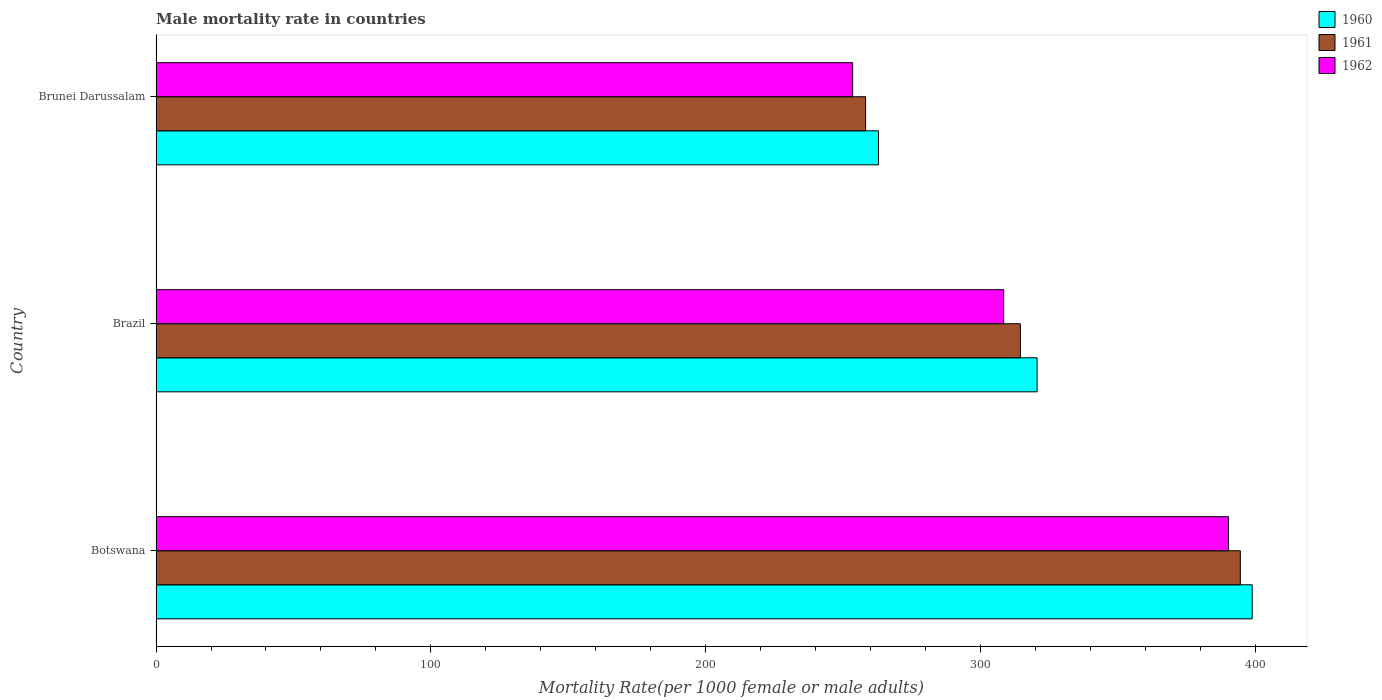How many groups of bars are there?
Offer a very short reply. 3. What is the label of the 3rd group of bars from the top?
Provide a succinct answer. Botswana. What is the male mortality rate in 1961 in Botswana?
Your answer should be compact. 394.41. Across all countries, what is the maximum male mortality rate in 1961?
Give a very brief answer. 394.41. Across all countries, what is the minimum male mortality rate in 1961?
Give a very brief answer. 258.09. In which country was the male mortality rate in 1960 maximum?
Provide a short and direct response. Botswana. In which country was the male mortality rate in 1962 minimum?
Offer a terse response. Brunei Darussalam. What is the total male mortality rate in 1961 in the graph?
Your answer should be compact. 966.9. What is the difference between the male mortality rate in 1960 in Botswana and that in Brazil?
Provide a short and direct response. 78.24. What is the difference between the male mortality rate in 1960 in Brunei Darussalam and the male mortality rate in 1962 in Botswana?
Ensure brevity in your answer.  -127.32. What is the average male mortality rate in 1962 per country?
Your response must be concise. 317.27. What is the difference between the male mortality rate in 1961 and male mortality rate in 1962 in Botswana?
Give a very brief answer. 4.3. What is the ratio of the male mortality rate in 1961 in Botswana to that in Brunei Darussalam?
Make the answer very short. 1.53. What is the difference between the highest and the second highest male mortality rate in 1962?
Offer a very short reply. 81.78. What is the difference between the highest and the lowest male mortality rate in 1960?
Your response must be concise. 135.93. In how many countries, is the male mortality rate in 1962 greater than the average male mortality rate in 1962 taken over all countries?
Offer a very short reply. 1. Is it the case that in every country, the sum of the male mortality rate in 1961 and male mortality rate in 1960 is greater than the male mortality rate in 1962?
Ensure brevity in your answer.  Yes. Are all the bars in the graph horizontal?
Offer a very short reply. Yes. How many countries are there in the graph?
Make the answer very short. 3. How many legend labels are there?
Offer a very short reply. 3. How are the legend labels stacked?
Give a very brief answer. Vertical. What is the title of the graph?
Make the answer very short. Male mortality rate in countries. Does "2008" appear as one of the legend labels in the graph?
Your answer should be compact. No. What is the label or title of the X-axis?
Provide a succinct answer. Mortality Rate(per 1000 female or male adults). What is the Mortality Rate(per 1000 female or male adults) in 1960 in Botswana?
Ensure brevity in your answer.  398.72. What is the Mortality Rate(per 1000 female or male adults) in 1961 in Botswana?
Offer a terse response. 394.41. What is the Mortality Rate(per 1000 female or male adults) of 1962 in Botswana?
Offer a very short reply. 390.11. What is the Mortality Rate(per 1000 female or male adults) of 1960 in Brazil?
Offer a very short reply. 320.48. What is the Mortality Rate(per 1000 female or male adults) of 1961 in Brazil?
Provide a short and direct response. 314.4. What is the Mortality Rate(per 1000 female or male adults) of 1962 in Brazil?
Give a very brief answer. 308.32. What is the Mortality Rate(per 1000 female or male adults) of 1960 in Brunei Darussalam?
Provide a short and direct response. 262.79. What is the Mortality Rate(per 1000 female or male adults) in 1961 in Brunei Darussalam?
Your response must be concise. 258.09. What is the Mortality Rate(per 1000 female or male adults) in 1962 in Brunei Darussalam?
Your answer should be very brief. 253.39. Across all countries, what is the maximum Mortality Rate(per 1000 female or male adults) in 1960?
Offer a terse response. 398.72. Across all countries, what is the maximum Mortality Rate(per 1000 female or male adults) in 1961?
Ensure brevity in your answer.  394.41. Across all countries, what is the maximum Mortality Rate(per 1000 female or male adults) of 1962?
Provide a short and direct response. 390.11. Across all countries, what is the minimum Mortality Rate(per 1000 female or male adults) in 1960?
Your response must be concise. 262.79. Across all countries, what is the minimum Mortality Rate(per 1000 female or male adults) in 1961?
Keep it short and to the point. 258.09. Across all countries, what is the minimum Mortality Rate(per 1000 female or male adults) of 1962?
Your answer should be compact. 253.39. What is the total Mortality Rate(per 1000 female or male adults) in 1960 in the graph?
Provide a succinct answer. 981.98. What is the total Mortality Rate(per 1000 female or male adults) in 1961 in the graph?
Your response must be concise. 966.9. What is the total Mortality Rate(per 1000 female or male adults) in 1962 in the graph?
Offer a terse response. 951.82. What is the difference between the Mortality Rate(per 1000 female or male adults) in 1960 in Botswana and that in Brazil?
Make the answer very short. 78.24. What is the difference between the Mortality Rate(per 1000 female or male adults) in 1961 in Botswana and that in Brazil?
Your response must be concise. 80.01. What is the difference between the Mortality Rate(per 1000 female or male adults) of 1962 in Botswana and that in Brazil?
Ensure brevity in your answer.  81.78. What is the difference between the Mortality Rate(per 1000 female or male adults) of 1960 in Botswana and that in Brunei Darussalam?
Your response must be concise. 135.93. What is the difference between the Mortality Rate(per 1000 female or male adults) of 1961 in Botswana and that in Brunei Darussalam?
Make the answer very short. 136.32. What is the difference between the Mortality Rate(per 1000 female or male adults) of 1962 in Botswana and that in Brunei Darussalam?
Provide a succinct answer. 136.72. What is the difference between the Mortality Rate(per 1000 female or male adults) in 1960 in Brazil and that in Brunei Darussalam?
Your answer should be compact. 57.69. What is the difference between the Mortality Rate(per 1000 female or male adults) of 1961 in Brazil and that in Brunei Darussalam?
Ensure brevity in your answer.  56.31. What is the difference between the Mortality Rate(per 1000 female or male adults) of 1962 in Brazil and that in Brunei Darussalam?
Offer a very short reply. 54.94. What is the difference between the Mortality Rate(per 1000 female or male adults) in 1960 in Botswana and the Mortality Rate(per 1000 female or male adults) in 1961 in Brazil?
Offer a terse response. 84.32. What is the difference between the Mortality Rate(per 1000 female or male adults) in 1960 in Botswana and the Mortality Rate(per 1000 female or male adults) in 1962 in Brazil?
Offer a very short reply. 90.39. What is the difference between the Mortality Rate(per 1000 female or male adults) in 1961 in Botswana and the Mortality Rate(per 1000 female or male adults) in 1962 in Brazil?
Make the answer very short. 86.09. What is the difference between the Mortality Rate(per 1000 female or male adults) of 1960 in Botswana and the Mortality Rate(per 1000 female or male adults) of 1961 in Brunei Darussalam?
Give a very brief answer. 140.63. What is the difference between the Mortality Rate(per 1000 female or male adults) of 1960 in Botswana and the Mortality Rate(per 1000 female or male adults) of 1962 in Brunei Darussalam?
Make the answer very short. 145.33. What is the difference between the Mortality Rate(per 1000 female or male adults) in 1961 in Botswana and the Mortality Rate(per 1000 female or male adults) in 1962 in Brunei Darussalam?
Your answer should be very brief. 141.02. What is the difference between the Mortality Rate(per 1000 female or male adults) of 1960 in Brazil and the Mortality Rate(per 1000 female or male adults) of 1961 in Brunei Darussalam?
Your response must be concise. 62.39. What is the difference between the Mortality Rate(per 1000 female or male adults) in 1960 in Brazil and the Mortality Rate(per 1000 female or male adults) in 1962 in Brunei Darussalam?
Your answer should be compact. 67.09. What is the difference between the Mortality Rate(per 1000 female or male adults) of 1961 in Brazil and the Mortality Rate(per 1000 female or male adults) of 1962 in Brunei Darussalam?
Provide a short and direct response. 61.01. What is the average Mortality Rate(per 1000 female or male adults) of 1960 per country?
Ensure brevity in your answer.  327.33. What is the average Mortality Rate(per 1000 female or male adults) in 1961 per country?
Provide a succinct answer. 322.3. What is the average Mortality Rate(per 1000 female or male adults) in 1962 per country?
Keep it short and to the point. 317.27. What is the difference between the Mortality Rate(per 1000 female or male adults) of 1960 and Mortality Rate(per 1000 female or male adults) of 1961 in Botswana?
Your answer should be compact. 4.3. What is the difference between the Mortality Rate(per 1000 female or male adults) of 1960 and Mortality Rate(per 1000 female or male adults) of 1962 in Botswana?
Your answer should be compact. 8.61. What is the difference between the Mortality Rate(per 1000 female or male adults) of 1961 and Mortality Rate(per 1000 female or male adults) of 1962 in Botswana?
Offer a very short reply. 4.3. What is the difference between the Mortality Rate(per 1000 female or male adults) in 1960 and Mortality Rate(per 1000 female or male adults) in 1961 in Brazil?
Provide a short and direct response. 6.08. What is the difference between the Mortality Rate(per 1000 female or male adults) of 1960 and Mortality Rate(per 1000 female or male adults) of 1962 in Brazil?
Give a very brief answer. 12.15. What is the difference between the Mortality Rate(per 1000 female or male adults) in 1961 and Mortality Rate(per 1000 female or male adults) in 1962 in Brazil?
Provide a succinct answer. 6.08. What is the difference between the Mortality Rate(per 1000 female or male adults) of 1960 and Mortality Rate(per 1000 female or male adults) of 1961 in Brunei Darussalam?
Provide a short and direct response. 4.7. What is the difference between the Mortality Rate(per 1000 female or male adults) of 1960 and Mortality Rate(per 1000 female or male adults) of 1962 in Brunei Darussalam?
Make the answer very short. 9.4. What is the ratio of the Mortality Rate(per 1000 female or male adults) of 1960 in Botswana to that in Brazil?
Keep it short and to the point. 1.24. What is the ratio of the Mortality Rate(per 1000 female or male adults) of 1961 in Botswana to that in Brazil?
Ensure brevity in your answer.  1.25. What is the ratio of the Mortality Rate(per 1000 female or male adults) in 1962 in Botswana to that in Brazil?
Offer a terse response. 1.27. What is the ratio of the Mortality Rate(per 1000 female or male adults) in 1960 in Botswana to that in Brunei Darussalam?
Keep it short and to the point. 1.52. What is the ratio of the Mortality Rate(per 1000 female or male adults) of 1961 in Botswana to that in Brunei Darussalam?
Offer a very short reply. 1.53. What is the ratio of the Mortality Rate(per 1000 female or male adults) in 1962 in Botswana to that in Brunei Darussalam?
Give a very brief answer. 1.54. What is the ratio of the Mortality Rate(per 1000 female or male adults) in 1960 in Brazil to that in Brunei Darussalam?
Provide a succinct answer. 1.22. What is the ratio of the Mortality Rate(per 1000 female or male adults) of 1961 in Brazil to that in Brunei Darussalam?
Make the answer very short. 1.22. What is the ratio of the Mortality Rate(per 1000 female or male adults) in 1962 in Brazil to that in Brunei Darussalam?
Your answer should be compact. 1.22. What is the difference between the highest and the second highest Mortality Rate(per 1000 female or male adults) in 1960?
Provide a succinct answer. 78.24. What is the difference between the highest and the second highest Mortality Rate(per 1000 female or male adults) of 1961?
Your response must be concise. 80.01. What is the difference between the highest and the second highest Mortality Rate(per 1000 female or male adults) in 1962?
Offer a terse response. 81.78. What is the difference between the highest and the lowest Mortality Rate(per 1000 female or male adults) of 1960?
Keep it short and to the point. 135.93. What is the difference between the highest and the lowest Mortality Rate(per 1000 female or male adults) in 1961?
Your answer should be very brief. 136.32. What is the difference between the highest and the lowest Mortality Rate(per 1000 female or male adults) in 1962?
Offer a very short reply. 136.72. 